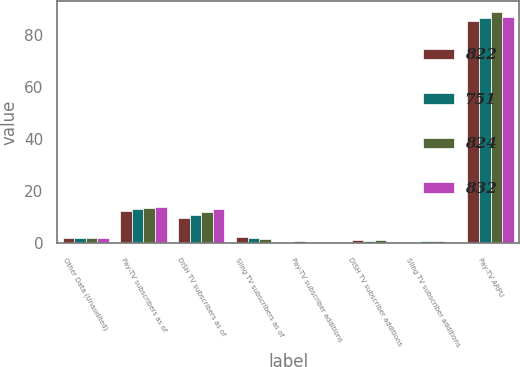<chart> <loc_0><loc_0><loc_500><loc_500><stacked_bar_chart><ecel><fcel>Other Data (Unaudited)<fcel>Pay-TV subscribers as of<fcel>DISH TV subscribers as of<fcel>Sling TV subscribers as of<fcel>Pay-TV subscriber additions<fcel>DISH TV subscriber additions<fcel>Sling TV subscriber additions<fcel>Pay-TV ARPU<nl><fcel>822<fcel>1.855<fcel>12.32<fcel>9.9<fcel>2.42<fcel>0.92<fcel>1.12<fcel>0.2<fcel>85.46<nl><fcel>751<fcel>1.855<fcel>13.24<fcel>11.03<fcel>2.21<fcel>0.28<fcel>0.99<fcel>0.71<fcel>86.43<nl><fcel>824<fcel>1.855<fcel>13.67<fcel>12.17<fcel>1.5<fcel>0.39<fcel>1.27<fcel>0.88<fcel>88.66<nl><fcel>832<fcel>1.855<fcel>13.9<fcel>13.27<fcel>0.62<fcel>0.08<fcel>0.61<fcel>0.53<fcel>86.79<nl></chart> 